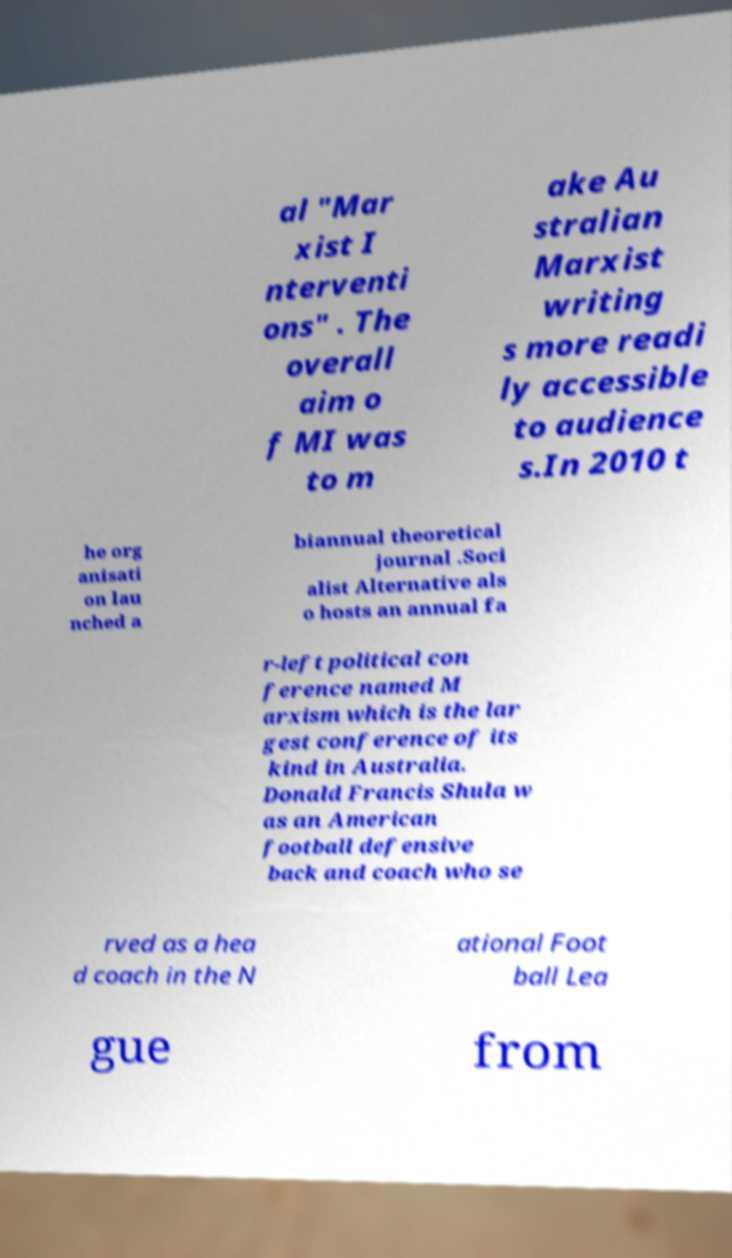There's text embedded in this image that I need extracted. Can you transcribe it verbatim? al "Mar xist I nterventi ons" . The overall aim o f MI was to m ake Au stralian Marxist writing s more readi ly accessible to audience s.In 2010 t he org anisati on lau nched a biannual theoretical journal .Soci alist Alternative als o hosts an annual fa r-left political con ference named M arxism which is the lar gest conference of its kind in Australia. Donald Francis Shula w as an American football defensive back and coach who se rved as a hea d coach in the N ational Foot ball Lea gue from 